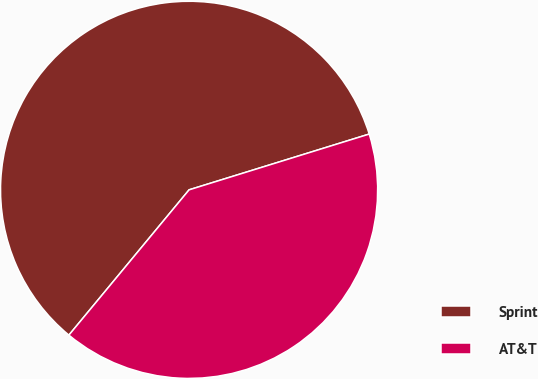Convert chart. <chart><loc_0><loc_0><loc_500><loc_500><pie_chart><fcel>Sprint<fcel>AT&T<nl><fcel>59.22%<fcel>40.78%<nl></chart> 